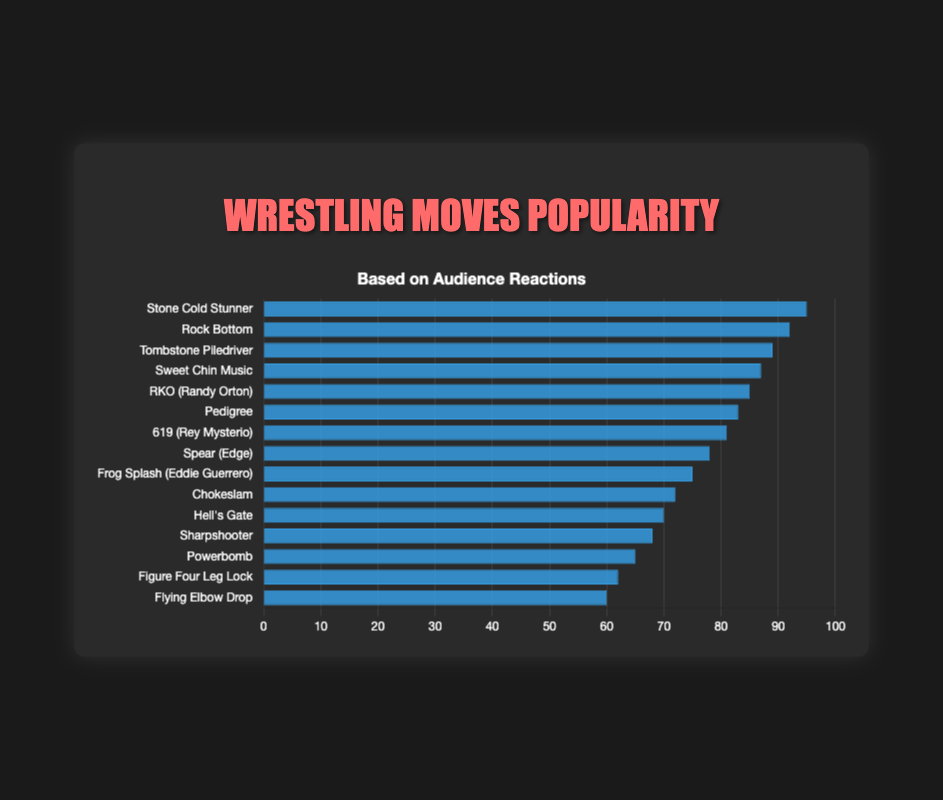Which wrestling move has the highest popularity rating? The figure shows the popularity ratings of different wrestling moves. By observing the heights of the blue bars, the "Stone Cold Stunner" has the highest bar, indicating it's the most popular move.
Answer: Stone Cold Stunner What is the difference in popularity rating between "Rock Bottom" and "Sweet Chin Music"? From the figure, "Rock Bottom" has a popularity rating of 92, and "Sweet Chin Music" has a rating of 87. The difference can be calculated as 92 - 87.
Answer: 5 Which wrestling move has a lower popularity rating, "Tombstone Piledriver" or "Pedigree"? By comparing the heights of the blue bars, "Tombstone Piledriver" has a popularity rating of 89, and "Pedigree" has 83, so "Pedigree" has a lower popularity rating.
Answer: Pedigree If you combine the popularity ratings of "RKO (Randy Orton)" and "Chokeslam," what would be the total? The individual popularity ratings are 85 for "RKO (Randy Orton)" and 72 for "Chokeslam." Adding these gives 85 + 72.
Answer: 157 Which of the following has the higher popularity, "Frog Splash (Eddie Guerrero)" or "619 (Rey Mysterio)"? The popularity rating for "619 (Rey Mysterio)" is 81, and for "Frog Splash (Eddie Guerrero)" is 75, so "619 (Rey Mysterio)" has the higher rating.
Answer: 619 (Rey Mysterio) How many moves have a popularity rating above 80? By counting the bars with a height representing a popularity rating above 80, we have six moves: "Stone Cold Stunner," "Rock Bottom," "Tombstone Piledriver," "Sweet Chin Music," "RKO (Randy Orton)," and "Pedigree."
Answer: 6 Which has a higher popularity rating: "Hell's Gate" or "Sharpshooter"? Observing the bars, "Hell's Gate" has a rating of 70 and "Sharpshooter" has 68, so "Hell's Gate" is higher.
Answer: Hell's Gate What is the average popularity rating of "Stone Cold Stunner," "Rock Bottom," and "Tombstone Piledriver"? The ratings for these moves are 95, 92, and 89, respectively. The average is calculated as (95 + 92 + 89) / 3.
Answer: 92 What color are the bars representing the popularity ratings of wrestling moves? The visual appearance of the chart shows that the bars are a shade of blue.
Answer: Blue What is the popularity rating of the least popular move? The figure indicates the "Flying Elbow Drop" has the lowest bar, with a popularity rating of 60.
Answer: 60 